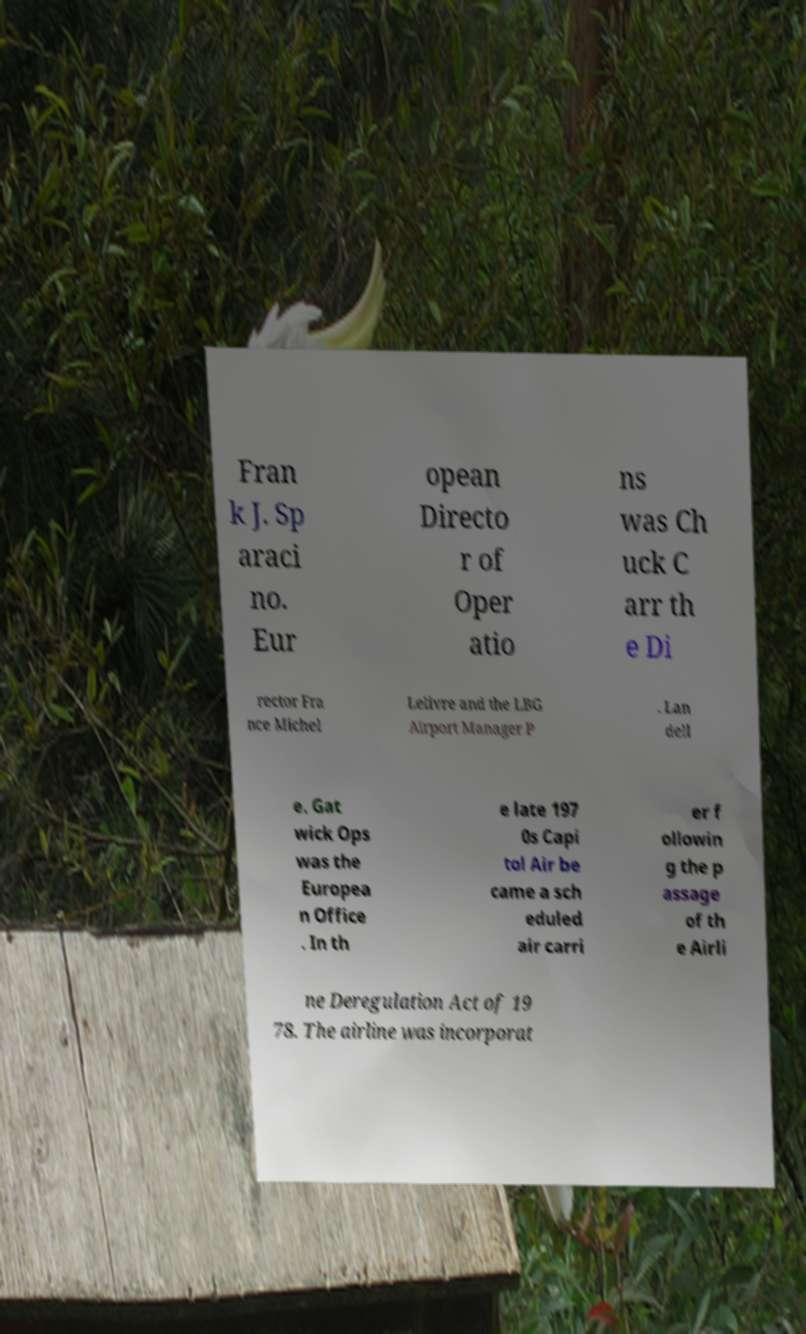There's text embedded in this image that I need extracted. Can you transcribe it verbatim? Fran k J. Sp araci no. Eur opean Directo r of Oper atio ns was Ch uck C arr th e Di rector Fra nce Michel Lelivre and the LBG Airport Manager P . Lan dell e. Gat wick Ops was the Europea n Office . In th e late 197 0s Capi tol Air be came a sch eduled air carri er f ollowin g the p assage of th e Airli ne Deregulation Act of 19 78. The airline was incorporat 